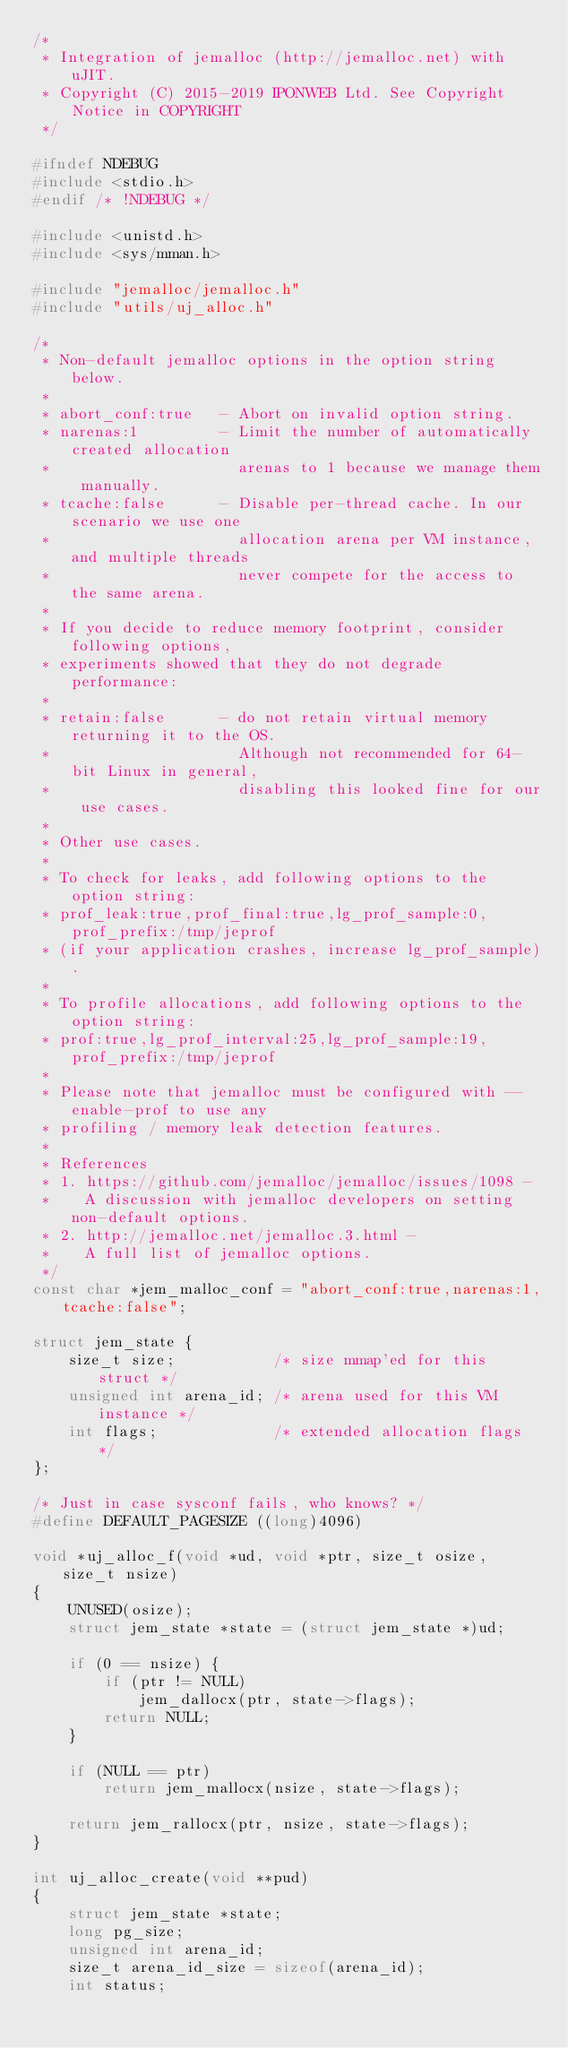<code> <loc_0><loc_0><loc_500><loc_500><_C_>/*
 * Integration of jemalloc (http://jemalloc.net) with uJIT.
 * Copyright (C) 2015-2019 IPONWEB Ltd. See Copyright Notice in COPYRIGHT
 */

#ifndef NDEBUG
#include <stdio.h>
#endif /* !NDEBUG */

#include <unistd.h>
#include <sys/mman.h>

#include "jemalloc/jemalloc.h"
#include "utils/uj_alloc.h"

/*
 * Non-default jemalloc options in the option string below.
 *
 * abort_conf:true   - Abort on invalid option string.
 * narenas:1         - Limit the number of automatically created allocation
 *                     arenas to 1 because we manage them manually.
 * tcache:false      - Disable per-thread cache. In our scenario we use one
 *                     allocation arena per VM instance, and multiple threads
 *                     never compete for the access to the same arena.
 *
 * If you decide to reduce memory footprint, consider following options,
 * experiments showed that they do not degrade performance:
 *
 * retain:false      - do not retain virtual memory returning it to the OS.
 *                     Although not recommended for 64-bit Linux in general,
 *                     disabling this looked fine for our use cases.
 *
 * Other use cases.
 *
 * To check for leaks, add following options to the option string:
 * prof_leak:true,prof_final:true,lg_prof_sample:0,prof_prefix:/tmp/jeprof
 * (if your application crashes, increase lg_prof_sample).
 *
 * To profile allocations, add following options to the option string:
 * prof:true,lg_prof_interval:25,lg_prof_sample:19,prof_prefix:/tmp/jeprof
 *
 * Please note that jemalloc must be configured with --enable-prof to use any
 * profiling / memory leak detection features.
 *
 * References
 * 1. https://github.com/jemalloc/jemalloc/issues/1098 -
 *    A discussion with jemalloc developers on setting non-default options.
 * 2. http://jemalloc.net/jemalloc.3.html -
 *    A full list of jemalloc options.
 */
const char *jem_malloc_conf = "abort_conf:true,narenas:1,tcache:false";

struct jem_state {
	size_t size;           /* size mmap'ed for this struct */
	unsigned int arena_id; /* arena used for this VM instance */
	int flags;             /* extended allocation flags */
};

/* Just in case sysconf fails, who knows? */
#define DEFAULT_PAGESIZE ((long)4096)

void *uj_alloc_f(void *ud, void *ptr, size_t osize, size_t nsize)
{
	UNUSED(osize);
	struct jem_state *state = (struct jem_state *)ud;

	if (0 == nsize) {
		if (ptr != NULL)
			jem_dallocx(ptr, state->flags);
		return NULL;
	}

	if (NULL == ptr)
		return jem_mallocx(nsize, state->flags);

	return jem_rallocx(ptr, nsize, state->flags);
}

int uj_alloc_create(void **pud)
{
	struct jem_state *state;
	long pg_size;
	unsigned int arena_id;
	size_t arena_id_size = sizeof(arena_id);
	int status;
</code> 